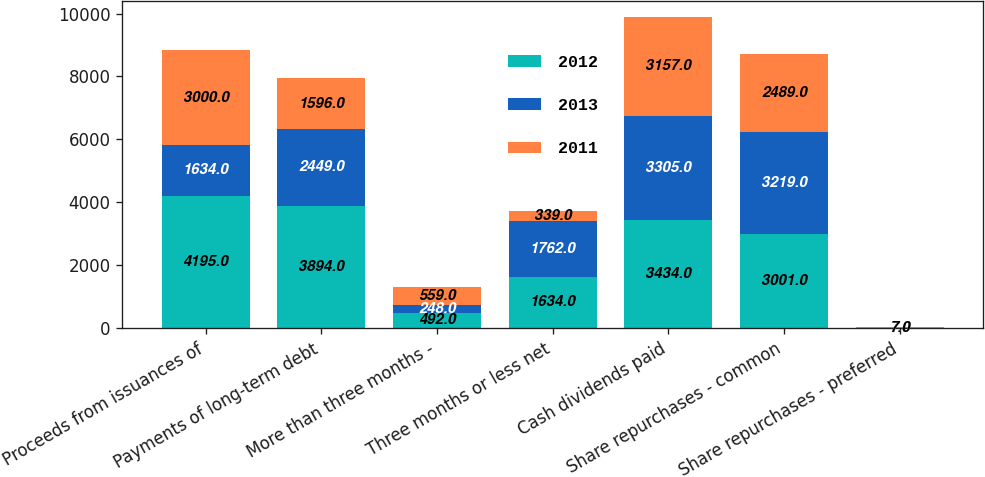Convert chart. <chart><loc_0><loc_0><loc_500><loc_500><stacked_bar_chart><ecel><fcel>Proceeds from issuances of<fcel>Payments of long-term debt<fcel>More than three months -<fcel>Three months or less net<fcel>Cash dividends paid<fcel>Share repurchases - common<fcel>Share repurchases - preferred<nl><fcel>2012<fcel>4195<fcel>3894<fcel>492<fcel>1634<fcel>3434<fcel>3001<fcel>7<nl><fcel>2013<fcel>1634<fcel>2449<fcel>248<fcel>1762<fcel>3305<fcel>3219<fcel>7<nl><fcel>2011<fcel>3000<fcel>1596<fcel>559<fcel>339<fcel>3157<fcel>2489<fcel>7<nl></chart> 